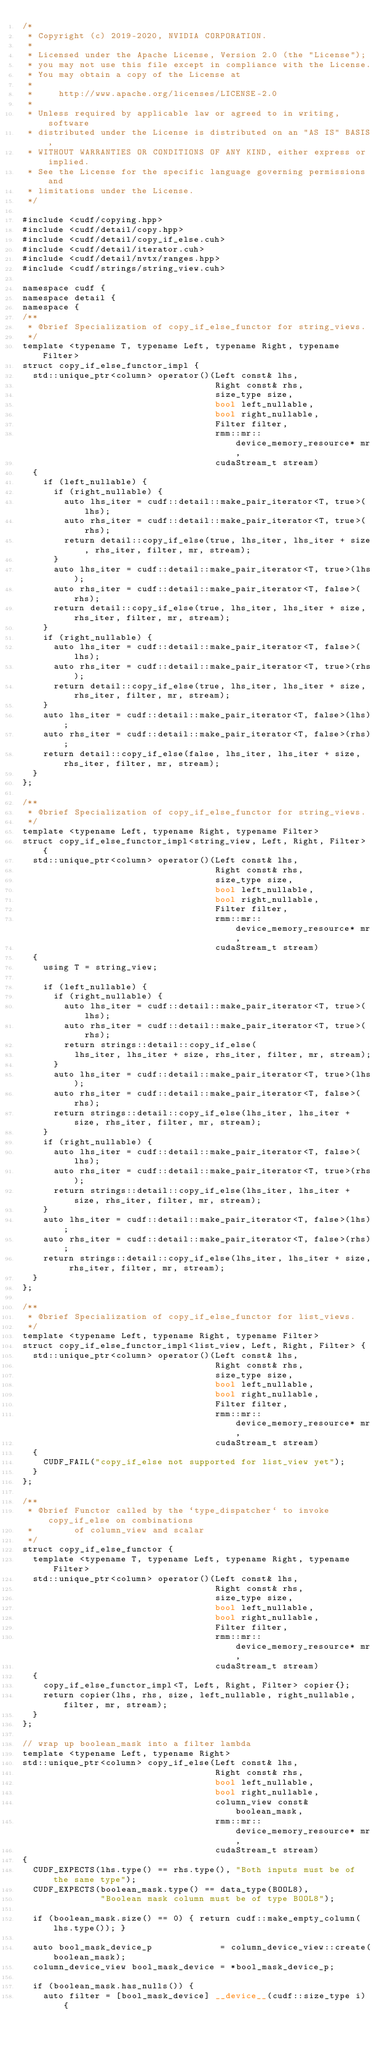<code> <loc_0><loc_0><loc_500><loc_500><_Cuda_>/*
 * Copyright (c) 2019-2020, NVIDIA CORPORATION.
 *
 * Licensed under the Apache License, Version 2.0 (the "License");
 * you may not use this file except in compliance with the License.
 * You may obtain a copy of the License at
 *
 *     http://www.apache.org/licenses/LICENSE-2.0
 *
 * Unless required by applicable law or agreed to in writing, software
 * distributed under the License is distributed on an "AS IS" BASIS,
 * WITHOUT WARRANTIES OR CONDITIONS OF ANY KIND, either express or implied.
 * See the License for the specific language governing permissions and
 * limitations under the License.
 */

#include <cudf/copying.hpp>
#include <cudf/detail/copy.hpp>
#include <cudf/detail/copy_if_else.cuh>
#include <cudf/detail/iterator.cuh>
#include <cudf/detail/nvtx/ranges.hpp>
#include <cudf/strings/string_view.cuh>

namespace cudf {
namespace detail {
namespace {
/**
 * @brief Specialization of copy_if_else_functor for string_views.
 */
template <typename T, typename Left, typename Right, typename Filter>
struct copy_if_else_functor_impl {
  std::unique_ptr<column> operator()(Left const& lhs,
                                     Right const& rhs,
                                     size_type size,
                                     bool left_nullable,
                                     bool right_nullable,
                                     Filter filter,
                                     rmm::mr::device_memory_resource* mr,
                                     cudaStream_t stream)
  {
    if (left_nullable) {
      if (right_nullable) {
        auto lhs_iter = cudf::detail::make_pair_iterator<T, true>(lhs);
        auto rhs_iter = cudf::detail::make_pair_iterator<T, true>(rhs);
        return detail::copy_if_else(true, lhs_iter, lhs_iter + size, rhs_iter, filter, mr, stream);
      }
      auto lhs_iter = cudf::detail::make_pair_iterator<T, true>(lhs);
      auto rhs_iter = cudf::detail::make_pair_iterator<T, false>(rhs);
      return detail::copy_if_else(true, lhs_iter, lhs_iter + size, rhs_iter, filter, mr, stream);
    }
    if (right_nullable) {
      auto lhs_iter = cudf::detail::make_pair_iterator<T, false>(lhs);
      auto rhs_iter = cudf::detail::make_pair_iterator<T, true>(rhs);
      return detail::copy_if_else(true, lhs_iter, lhs_iter + size, rhs_iter, filter, mr, stream);
    }
    auto lhs_iter = cudf::detail::make_pair_iterator<T, false>(lhs);
    auto rhs_iter = cudf::detail::make_pair_iterator<T, false>(rhs);
    return detail::copy_if_else(false, lhs_iter, lhs_iter + size, rhs_iter, filter, mr, stream);
  }
};

/**
 * @brief Specialization of copy_if_else_functor for string_views.
 */
template <typename Left, typename Right, typename Filter>
struct copy_if_else_functor_impl<string_view, Left, Right, Filter> {
  std::unique_ptr<column> operator()(Left const& lhs,
                                     Right const& rhs,
                                     size_type size,
                                     bool left_nullable,
                                     bool right_nullable,
                                     Filter filter,
                                     rmm::mr::device_memory_resource* mr,
                                     cudaStream_t stream)
  {
    using T = string_view;

    if (left_nullable) {
      if (right_nullable) {
        auto lhs_iter = cudf::detail::make_pair_iterator<T, true>(lhs);
        auto rhs_iter = cudf::detail::make_pair_iterator<T, true>(rhs);
        return strings::detail::copy_if_else(
          lhs_iter, lhs_iter + size, rhs_iter, filter, mr, stream);
      }
      auto lhs_iter = cudf::detail::make_pair_iterator<T, true>(lhs);
      auto rhs_iter = cudf::detail::make_pair_iterator<T, false>(rhs);
      return strings::detail::copy_if_else(lhs_iter, lhs_iter + size, rhs_iter, filter, mr, stream);
    }
    if (right_nullable) {
      auto lhs_iter = cudf::detail::make_pair_iterator<T, false>(lhs);
      auto rhs_iter = cudf::detail::make_pair_iterator<T, true>(rhs);
      return strings::detail::copy_if_else(lhs_iter, lhs_iter + size, rhs_iter, filter, mr, stream);
    }
    auto lhs_iter = cudf::detail::make_pair_iterator<T, false>(lhs);
    auto rhs_iter = cudf::detail::make_pair_iterator<T, false>(rhs);
    return strings::detail::copy_if_else(lhs_iter, lhs_iter + size, rhs_iter, filter, mr, stream);
  }
};

/**
 * @brief Specialization of copy_if_else_functor for list_views.
 */
template <typename Left, typename Right, typename Filter>
struct copy_if_else_functor_impl<list_view, Left, Right, Filter> {
  std::unique_ptr<column> operator()(Left const& lhs,
                                     Right const& rhs,
                                     size_type size,
                                     bool left_nullable,
                                     bool right_nullable,
                                     Filter filter,
                                     rmm::mr::device_memory_resource* mr,
                                     cudaStream_t stream)
  {
    CUDF_FAIL("copy_if_else not supported for list_view yet");
  }
};

/**
 * @brief Functor called by the `type_dispatcher` to invoke copy_if_else on combinations
 *        of column_view and scalar
 */
struct copy_if_else_functor {
  template <typename T, typename Left, typename Right, typename Filter>
  std::unique_ptr<column> operator()(Left const& lhs,
                                     Right const& rhs,
                                     size_type size,
                                     bool left_nullable,
                                     bool right_nullable,
                                     Filter filter,
                                     rmm::mr::device_memory_resource* mr,
                                     cudaStream_t stream)
  {
    copy_if_else_functor_impl<T, Left, Right, Filter> copier{};
    return copier(lhs, rhs, size, left_nullable, right_nullable, filter, mr, stream);
  }
};

// wrap up boolean_mask into a filter lambda
template <typename Left, typename Right>
std::unique_ptr<column> copy_if_else(Left const& lhs,
                                     Right const& rhs,
                                     bool left_nullable,
                                     bool right_nullable,
                                     column_view const& boolean_mask,
                                     rmm::mr::device_memory_resource* mr,
                                     cudaStream_t stream)
{
  CUDF_EXPECTS(lhs.type() == rhs.type(), "Both inputs must be of the same type");
  CUDF_EXPECTS(boolean_mask.type() == data_type(BOOL8),
               "Boolean mask column must be of type BOOL8");

  if (boolean_mask.size() == 0) { return cudf::make_empty_column(lhs.type()); }

  auto bool_mask_device_p             = column_device_view::create(boolean_mask);
  column_device_view bool_mask_device = *bool_mask_device_p;

  if (boolean_mask.has_nulls()) {
    auto filter = [bool_mask_device] __device__(cudf::size_type i) {</code> 